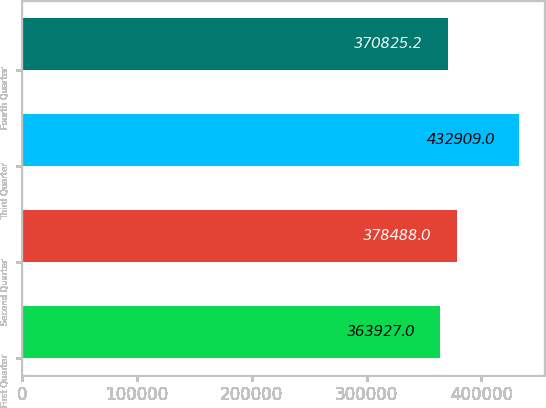Convert chart to OTSL. <chart><loc_0><loc_0><loc_500><loc_500><bar_chart><fcel>First Quarter<fcel>Second Quarter<fcel>Third Quarter<fcel>Fourth Quarter<nl><fcel>363927<fcel>378488<fcel>432909<fcel>370825<nl></chart> 